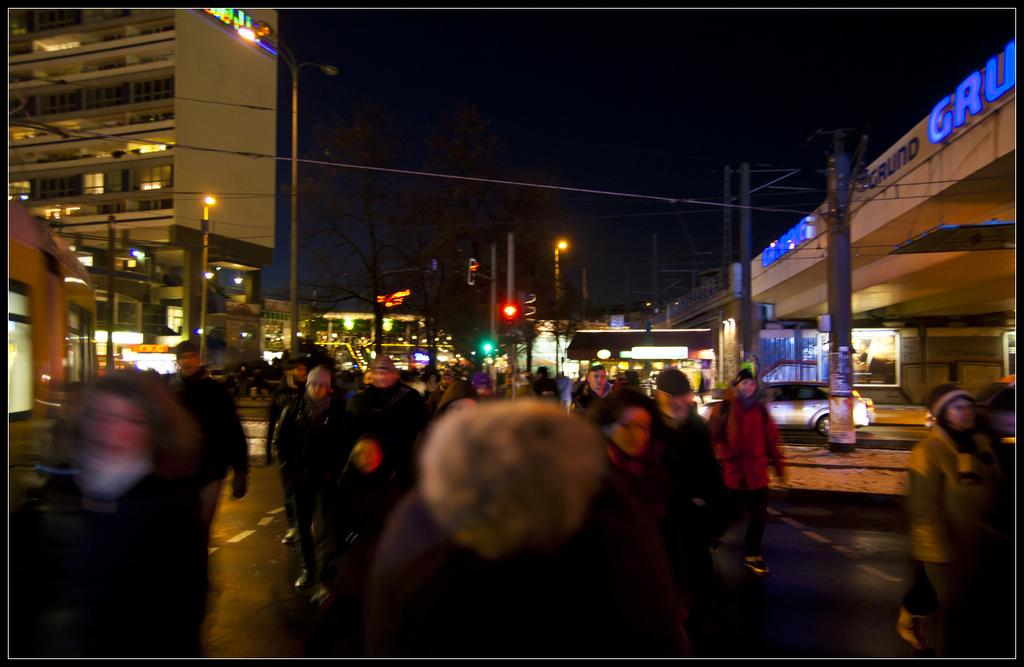What can be seen at the bottom of the image? There are people at the bottom of the image. What are the people doing? The people are walking. What is located in the middle of the image? There are vehicles, buildings, street lights, poles, trees, cables, and text in the middle of the image. What is visible in the image besides the people and objects in the middle? The sky is visible in the image. Are there any circles of cherries visible in the image? No, there are no circles of cherries present in the image. Can you see any juice being poured in the image? There is no juice being poured in the image. 